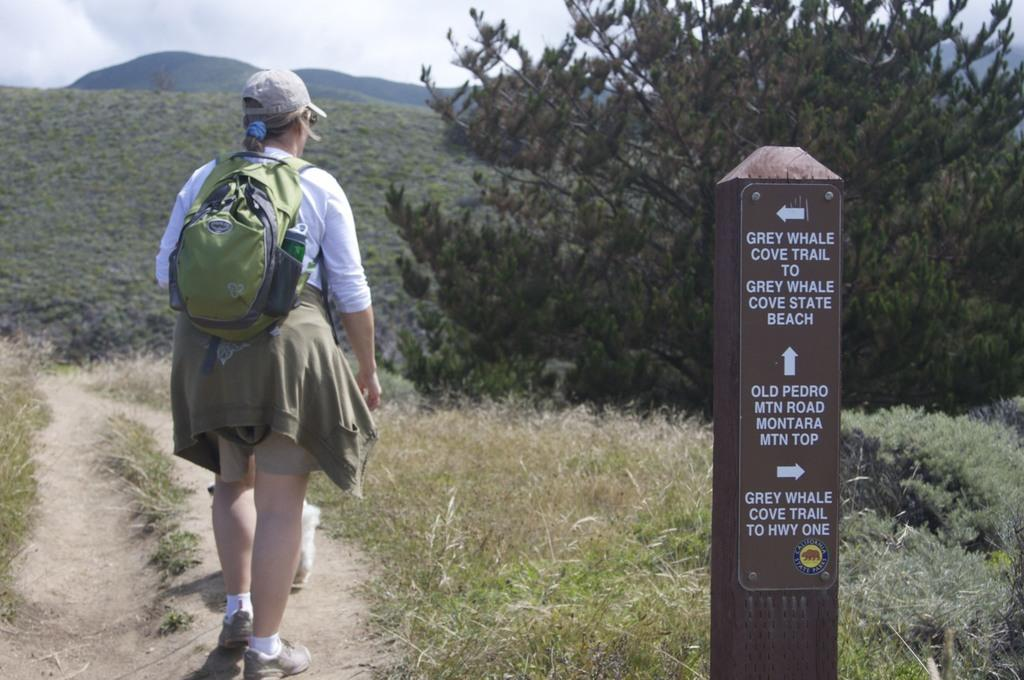Who is the main subject in the image? There is a woman in the image. What is the woman doing in the image? The woman is standing. What is the woman carrying in the image? The woman is carrying a backpack. What can be seen in the background of the image? There are trees in front of the woman. What type of vegetation is present on the ground in the image? The ground is filled with grass. What type of bait is the woman using to catch fish in the image? There is no indication in the image that the woman is fishing or using bait. What meal is the woman preparing in the image? There is no indication in the image that the woman is preparing a meal. 